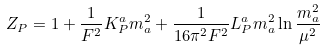Convert formula to latex. <formula><loc_0><loc_0><loc_500><loc_500>Z _ { P } = 1 + \frac { 1 } { F ^ { 2 } } K ^ { a } _ { P } m _ { a } ^ { 2 } + \frac { 1 } { 1 6 \pi ^ { 2 } F ^ { 2 } } L ^ { a } _ { P } m _ { a } ^ { 2 } \ln \frac { m _ { a } ^ { 2 } } { \mu ^ { 2 } }</formula> 